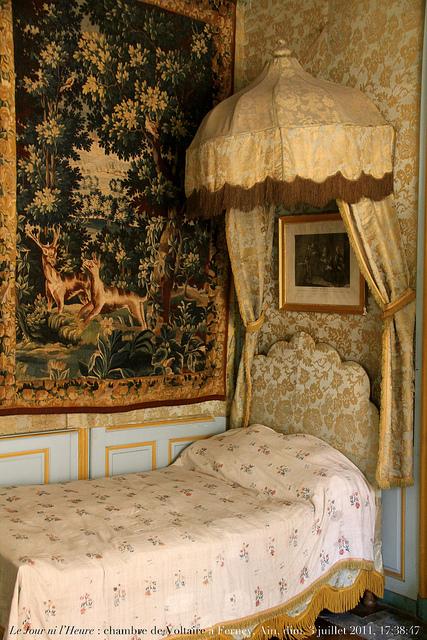Is this a single bed?
Answer briefly. Yes. What kind of room is this?
Be succinct. Bedroom. What is above the bed?
Write a very short answer. Canopy. 